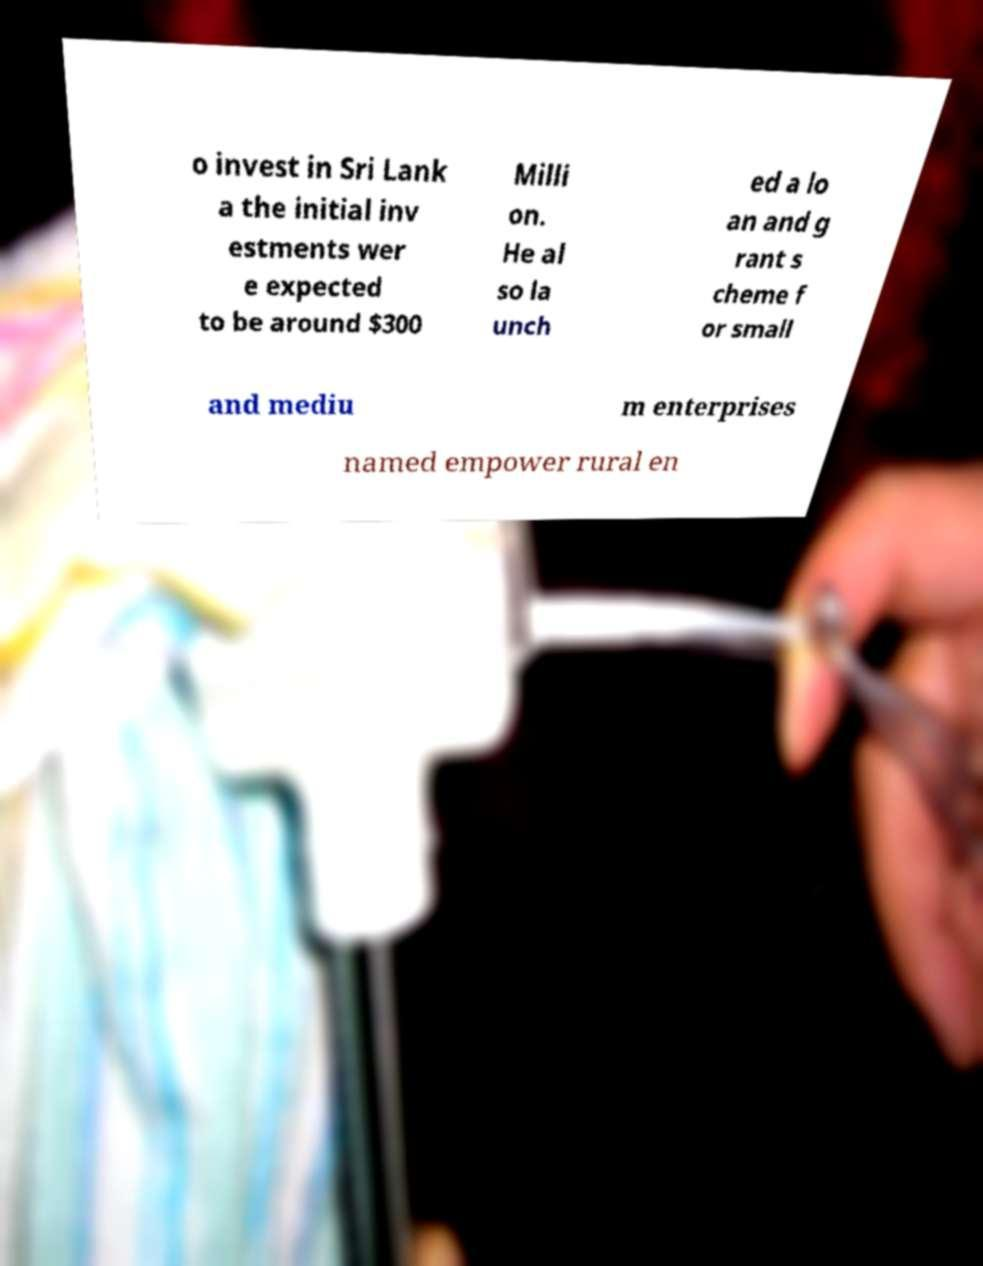Please read and relay the text visible in this image. What does it say? o invest in Sri Lank a the initial inv estments wer e expected to be around $300 Milli on. He al so la unch ed a lo an and g rant s cheme f or small and mediu m enterprises named empower rural en 